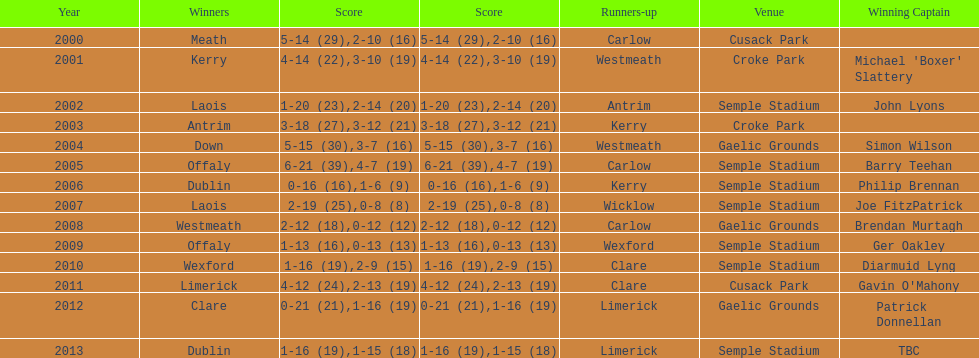How many times was carlow the runner-up? 3. 